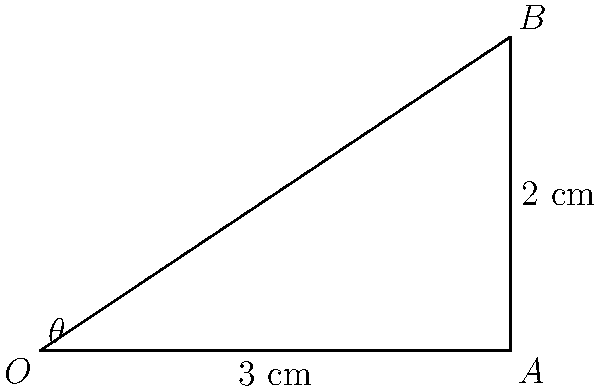As a general physician in Bad Axe, you need to administer an intramuscular injection. The injection site is 2 cm deep from the skin surface, and you want to insert the needle at a point 3 cm away from the injection site on the skin. At what angle $\theta$ should you insert the hypodermic needle to reach the injection site accurately? To solve this problem, we can use trigonometry, specifically the tangent function. Let's approach this step-by-step:

1) In the diagram, we have a right triangle OAB where:
   - O represents the insertion point on the skin
   - B represents the injection site
   - A is the point directly below B on the skin surface

2) We know:
   - OA = 3 cm (distance along the skin)
   - AB = 2 cm (depth of the injection site)

3) We need to find angle $\theta$ at point O.

4) In a right triangle, $\tan(\theta) = \frac{\text{opposite}}{\text{adjacent}}$

5) In this case: $\tan(\theta) = \frac{AB}{OA} = \frac{2}{3}$

6) To find $\theta$, we need to use the inverse tangent (arctan or $\tan^{-1}$):

   $\theta = \tan^{-1}(\frac{2}{3})$

7) Using a calculator or trigonometric tables:

   $\theta \approx 33.69°$

Therefore, you should insert the hypodermic needle at an angle of approximately 33.69° to the skin surface to accurately reach the injection site.
Answer: $33.69°$ 